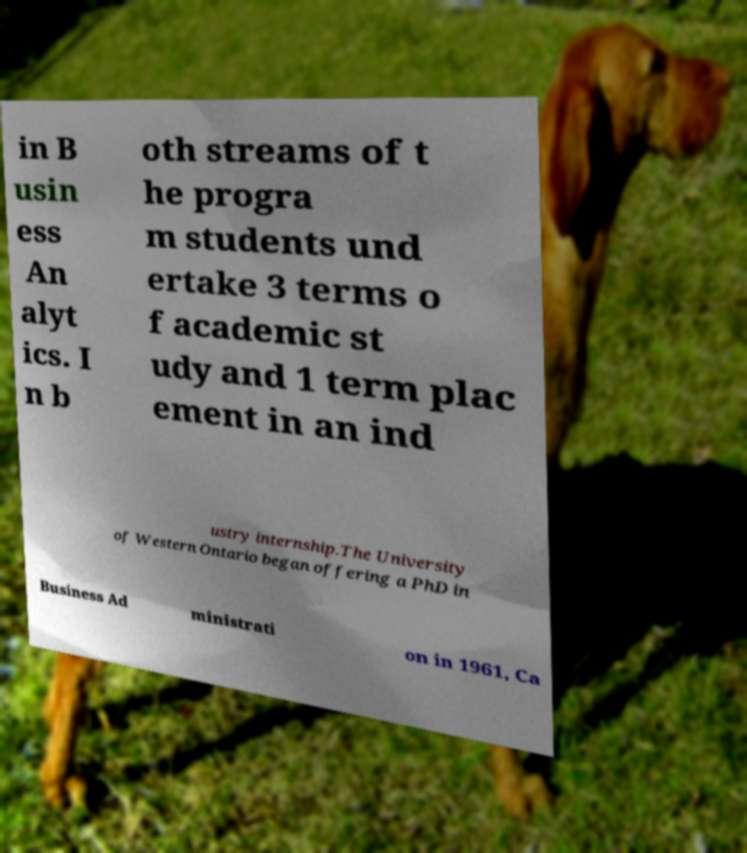Can you accurately transcribe the text from the provided image for me? in B usin ess An alyt ics. I n b oth streams of t he progra m students und ertake 3 terms o f academic st udy and 1 term plac ement in an ind ustry internship.The University of Western Ontario began offering a PhD in Business Ad ministrati on in 1961, Ca 